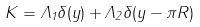Convert formula to latex. <formula><loc_0><loc_0><loc_500><loc_500>K = \Lambda _ { 1 } \delta ( y ) + \Lambda _ { 2 } \delta ( y - \pi R )</formula> 